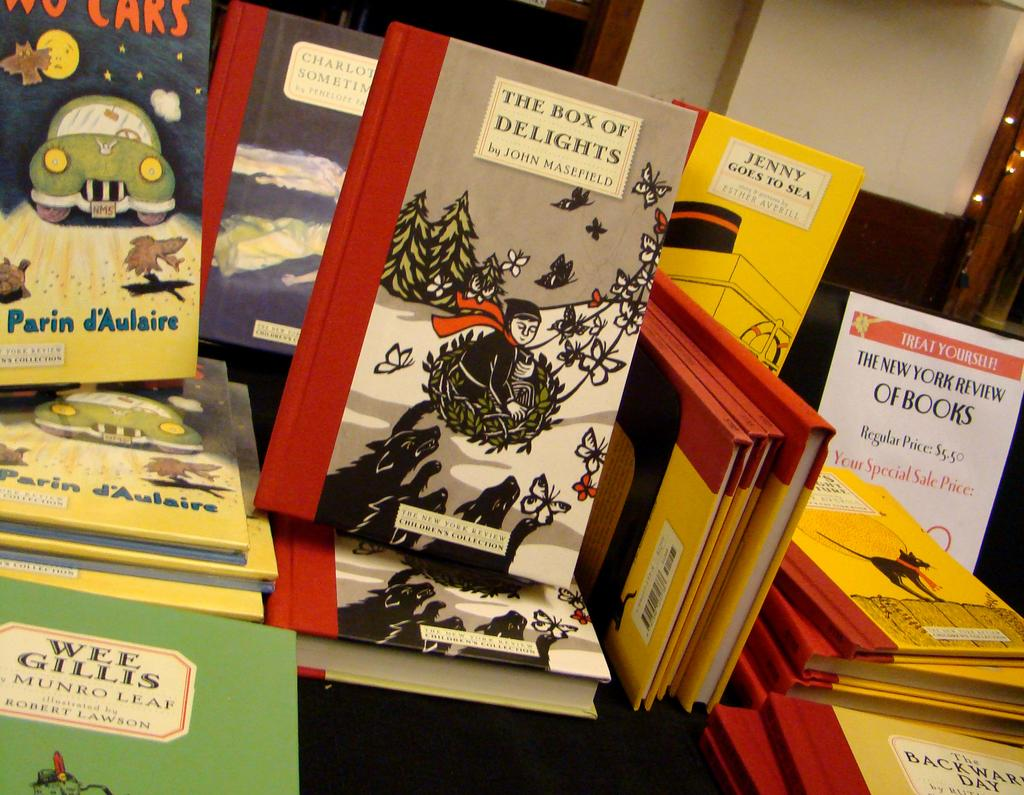What objects are in the foreground of the image? There are books in the foreground of the image. What can be seen in the background of the image? There are windows and a light source in the background of the image. Are there any architectural features visible in the background? Yes, there is a pillar in the background of the image. How many cards can be seen in the image? There are no cards present in the image. What type of tiger can be seen in the image? There is no tiger present in the image. 